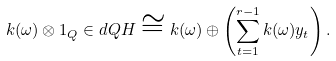Convert formula to latex. <formula><loc_0><loc_0><loc_500><loc_500>k ( \omega ) \otimes 1 _ { Q } \in d { Q } { H } \cong k ( \omega ) \oplus \left ( \sum _ { t = 1 } ^ { r - 1 } k ( \omega ) y _ { t } \right ) .</formula> 